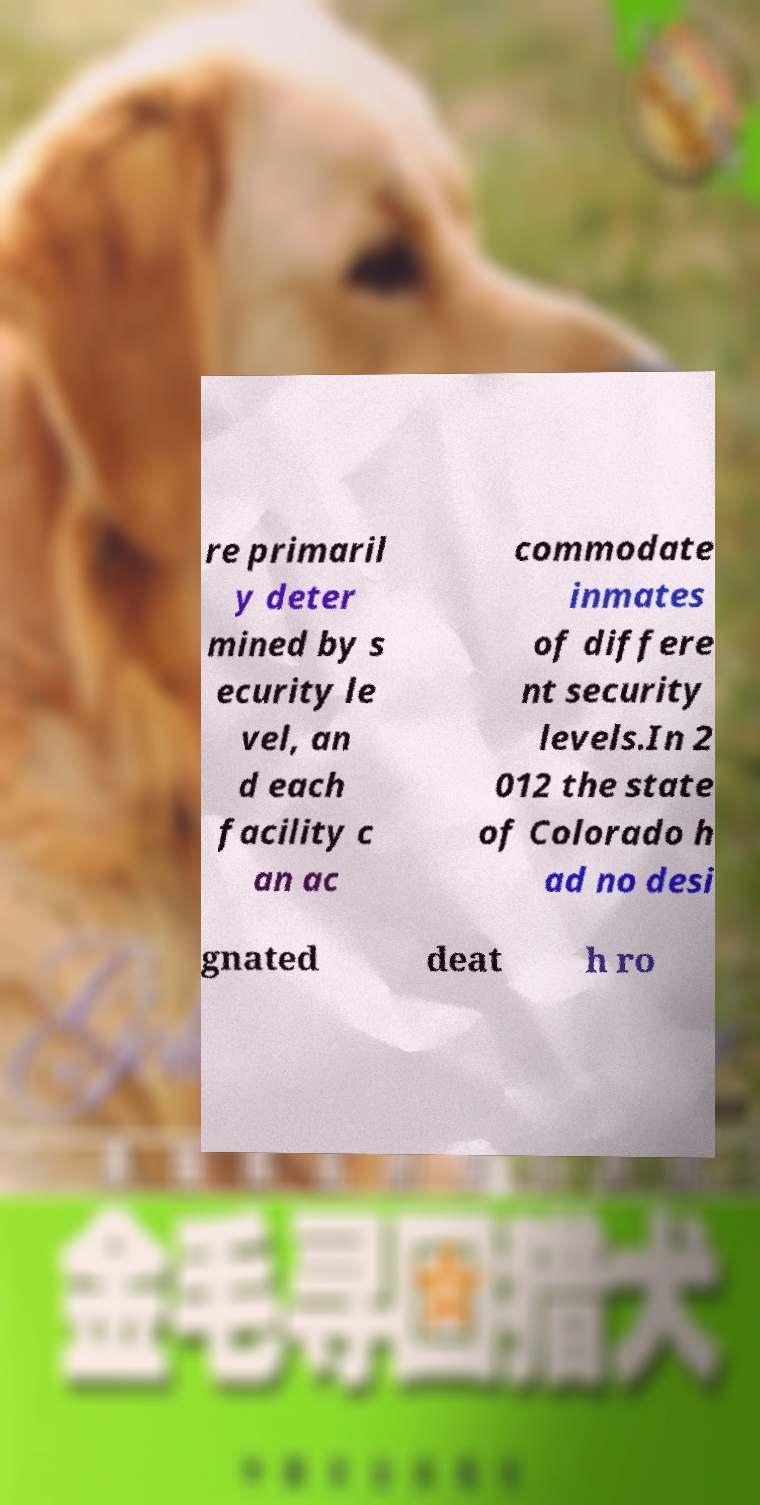Could you extract and type out the text from this image? re primaril y deter mined by s ecurity le vel, an d each facility c an ac commodate inmates of differe nt security levels.In 2 012 the state of Colorado h ad no desi gnated deat h ro 